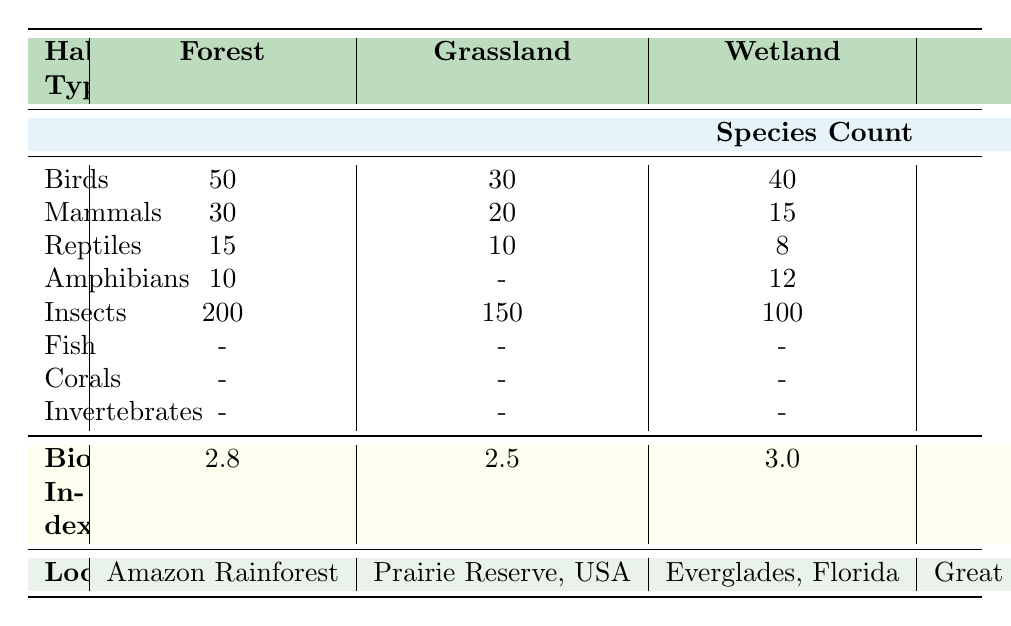What is the Biodiversity Index for the Coral Reef habitat? The Biodiversity Index for the Coral Reef habitat is clearly listed in the table under the "Biodiversity Index" row corresponding to that habitat. Therefore, it is 4.2.
Answer: 4.2 Which habitat has the highest number of Birds? The table shows the number of Birds for each habitat type; the Forest habitat has 50 Birds, which is higher than any other habitat listed. Therefore, the Forest has the highest number of Birds.
Answer: Forest How many Mammals are counted in the Wetland habitat? The number of Mammals in the Wetland habitat is provided in the Species Count section for that habitat. It states that there are 15 Mammals in the Wetland.
Answer: 15 What is the total number of species counted in Grassland? To find the total number of species in Grassland, we need to add the counts of all species available in the Grassland habitat as follows: 30 (Birds) + 20 (Mammals) + 10 (Reptiles) + 150 (Insects) = 210.
Answer: 210 Is the number of Amphibians greater than the number of Reptiles in the Forest habitat? The table indicates that there are 10 Amphibians and 15 Reptiles in the Forest habitat. Since 10 is less than 15, the statement is false.
Answer: No What is the difference between the Biodiversity Index of the Coral Reef and the Desert? The features listed in the table for both habitats show that the Coral Reef has a Biodiversity Index of 4.2, while the Desert has a Biodiversity Index of 1.7. By subtracting these, we find the difference: 4.2 - 1.7 = 2.5.
Answer: 2.5 Which habitat has the highest number of Insects and what is that number? The table lists the number of Insects for each habitat. Forest has 200, Grassland has 150, Wetland has 100, and Desert has 80, while Coral Reef has no count for Insects. The highest number of Insects is found in the Forest habitat with a count of 200.
Answer: Forest, 200 How many species are present in Coral Reef when compared to Wetland? The Coral Reef habitat has counts for Fish, Mammals, Reptiles, Corals, and Invertebrates, while Wetland has counts only for Birds, Mammals, Reptiles, Amphibians, and Insects. We find the total in Coral Reef: 100 (Fish) + 5 (Mammals) + 12 (Reptiles) + 50 (Corals) + 200 (Invertebrates) = 367, while Wetland totals 40 (Birds) + 15 (Mammals) + 8 (Reptiles) + 12 (Amphibians) + 100 (Insects) = 175. Coral Reef has more species.
Answer: Coral Reef has more species Are there any habitats with a Biodiversity Index below 2.0? By checking the Biodiversity Index values in the table, we see that the Desert is the only habitat that has a Biodiversity Index of 1.7, which is below 2.0. Thus, there is one habitat below that threshold.
Answer: Yes, Desert 